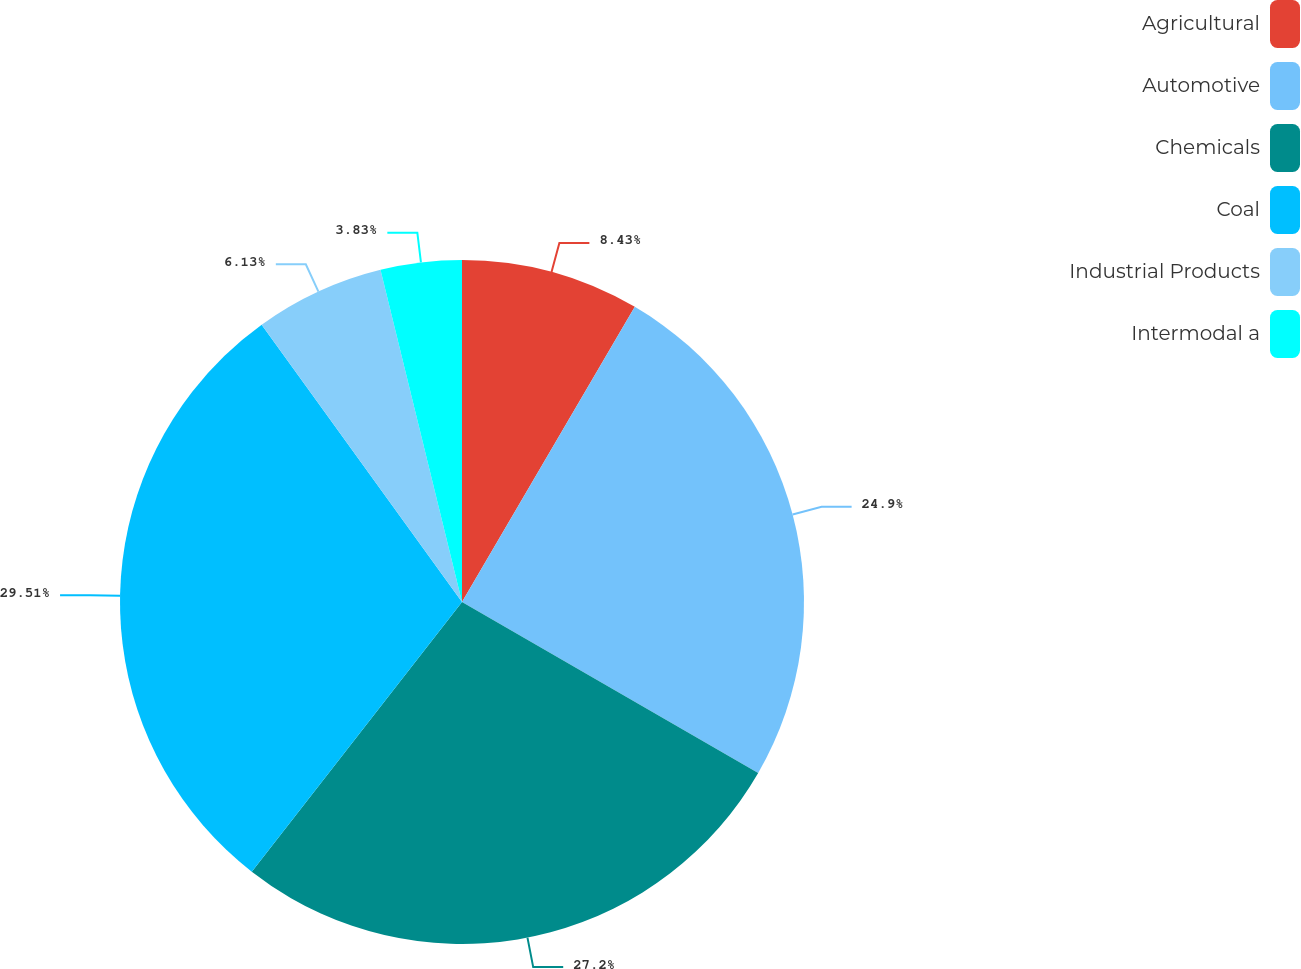Convert chart to OTSL. <chart><loc_0><loc_0><loc_500><loc_500><pie_chart><fcel>Agricultural<fcel>Automotive<fcel>Chemicals<fcel>Coal<fcel>Industrial Products<fcel>Intermodal a<nl><fcel>8.43%<fcel>24.9%<fcel>27.2%<fcel>29.5%<fcel>6.13%<fcel>3.83%<nl></chart> 